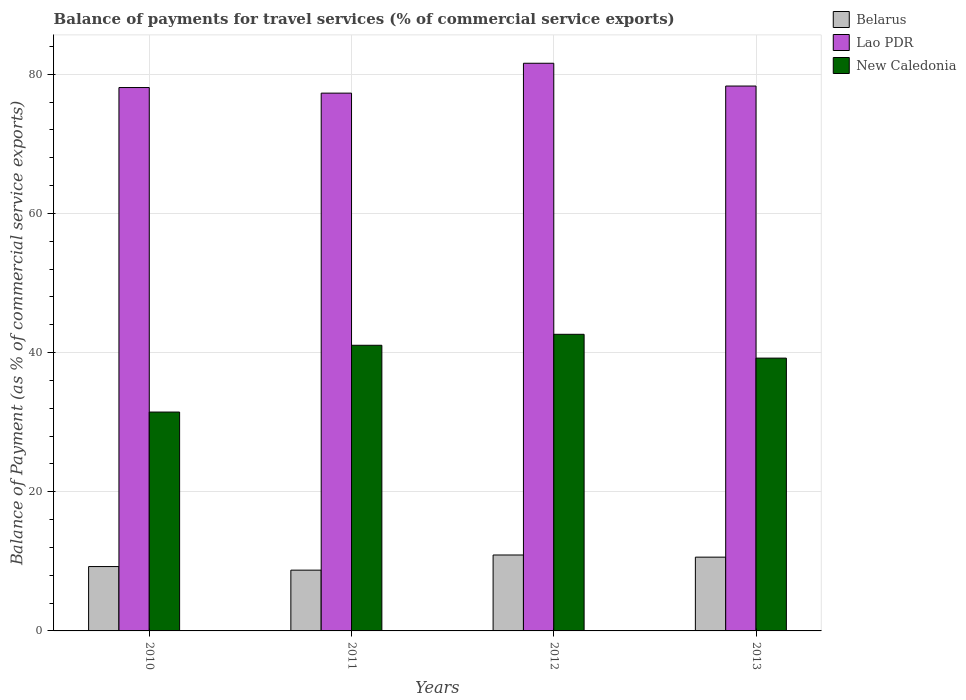How many bars are there on the 4th tick from the left?
Ensure brevity in your answer.  3. What is the label of the 4th group of bars from the left?
Make the answer very short. 2013. In how many cases, is the number of bars for a given year not equal to the number of legend labels?
Ensure brevity in your answer.  0. What is the balance of payments for travel services in Lao PDR in 2012?
Provide a short and direct response. 81.57. Across all years, what is the maximum balance of payments for travel services in New Caledonia?
Make the answer very short. 42.62. Across all years, what is the minimum balance of payments for travel services in New Caledonia?
Your response must be concise. 31.45. What is the total balance of payments for travel services in New Caledonia in the graph?
Keep it short and to the point. 154.33. What is the difference between the balance of payments for travel services in Belarus in 2010 and that in 2012?
Provide a succinct answer. -1.66. What is the difference between the balance of payments for travel services in New Caledonia in 2010 and the balance of payments for travel services in Belarus in 2012?
Make the answer very short. 20.54. What is the average balance of payments for travel services in Lao PDR per year?
Provide a short and direct response. 78.81. In the year 2011, what is the difference between the balance of payments for travel services in Lao PDR and balance of payments for travel services in New Caledonia?
Ensure brevity in your answer.  36.23. In how many years, is the balance of payments for travel services in Lao PDR greater than 64 %?
Provide a succinct answer. 4. What is the ratio of the balance of payments for travel services in Lao PDR in 2011 to that in 2013?
Make the answer very short. 0.99. Is the balance of payments for travel services in Lao PDR in 2011 less than that in 2012?
Give a very brief answer. Yes. Is the difference between the balance of payments for travel services in Lao PDR in 2011 and 2012 greater than the difference between the balance of payments for travel services in New Caledonia in 2011 and 2012?
Provide a short and direct response. No. What is the difference between the highest and the second highest balance of payments for travel services in New Caledonia?
Your answer should be compact. 1.57. What is the difference between the highest and the lowest balance of payments for travel services in Belarus?
Your answer should be very brief. 2.18. In how many years, is the balance of payments for travel services in New Caledonia greater than the average balance of payments for travel services in New Caledonia taken over all years?
Ensure brevity in your answer.  3. Is the sum of the balance of payments for travel services in Lao PDR in 2011 and 2013 greater than the maximum balance of payments for travel services in Belarus across all years?
Keep it short and to the point. Yes. What does the 1st bar from the left in 2011 represents?
Ensure brevity in your answer.  Belarus. What does the 3rd bar from the right in 2012 represents?
Offer a very short reply. Belarus. Is it the case that in every year, the sum of the balance of payments for travel services in Belarus and balance of payments for travel services in New Caledonia is greater than the balance of payments for travel services in Lao PDR?
Give a very brief answer. No. Are all the bars in the graph horizontal?
Make the answer very short. No. How many years are there in the graph?
Make the answer very short. 4. What is the difference between two consecutive major ticks on the Y-axis?
Keep it short and to the point. 20. Are the values on the major ticks of Y-axis written in scientific E-notation?
Ensure brevity in your answer.  No. Does the graph contain any zero values?
Offer a very short reply. No. Where does the legend appear in the graph?
Make the answer very short. Top right. What is the title of the graph?
Keep it short and to the point. Balance of payments for travel services (% of commercial service exports). What is the label or title of the Y-axis?
Keep it short and to the point. Balance of Payment (as % of commercial service exports). What is the Balance of Payment (as % of commercial service exports) in Belarus in 2010?
Offer a terse response. 9.25. What is the Balance of Payment (as % of commercial service exports) of Lao PDR in 2010?
Your answer should be very brief. 78.08. What is the Balance of Payment (as % of commercial service exports) in New Caledonia in 2010?
Your answer should be very brief. 31.45. What is the Balance of Payment (as % of commercial service exports) of Belarus in 2011?
Offer a terse response. 8.73. What is the Balance of Payment (as % of commercial service exports) of Lao PDR in 2011?
Provide a short and direct response. 77.28. What is the Balance of Payment (as % of commercial service exports) of New Caledonia in 2011?
Your answer should be very brief. 41.05. What is the Balance of Payment (as % of commercial service exports) in Belarus in 2012?
Your response must be concise. 10.91. What is the Balance of Payment (as % of commercial service exports) in Lao PDR in 2012?
Make the answer very short. 81.57. What is the Balance of Payment (as % of commercial service exports) of New Caledonia in 2012?
Make the answer very short. 42.62. What is the Balance of Payment (as % of commercial service exports) of Belarus in 2013?
Make the answer very short. 10.6. What is the Balance of Payment (as % of commercial service exports) in Lao PDR in 2013?
Your response must be concise. 78.3. What is the Balance of Payment (as % of commercial service exports) of New Caledonia in 2013?
Make the answer very short. 39.2. Across all years, what is the maximum Balance of Payment (as % of commercial service exports) of Belarus?
Give a very brief answer. 10.91. Across all years, what is the maximum Balance of Payment (as % of commercial service exports) in Lao PDR?
Your answer should be very brief. 81.57. Across all years, what is the maximum Balance of Payment (as % of commercial service exports) in New Caledonia?
Make the answer very short. 42.62. Across all years, what is the minimum Balance of Payment (as % of commercial service exports) of Belarus?
Provide a succinct answer. 8.73. Across all years, what is the minimum Balance of Payment (as % of commercial service exports) of Lao PDR?
Provide a succinct answer. 77.28. Across all years, what is the minimum Balance of Payment (as % of commercial service exports) of New Caledonia?
Provide a short and direct response. 31.45. What is the total Balance of Payment (as % of commercial service exports) of Belarus in the graph?
Offer a terse response. 39.49. What is the total Balance of Payment (as % of commercial service exports) of Lao PDR in the graph?
Your answer should be very brief. 315.24. What is the total Balance of Payment (as % of commercial service exports) in New Caledonia in the graph?
Offer a very short reply. 154.33. What is the difference between the Balance of Payment (as % of commercial service exports) of Belarus in 2010 and that in 2011?
Keep it short and to the point. 0.52. What is the difference between the Balance of Payment (as % of commercial service exports) in Lao PDR in 2010 and that in 2011?
Your answer should be very brief. 0.8. What is the difference between the Balance of Payment (as % of commercial service exports) in New Caledonia in 2010 and that in 2011?
Your answer should be very brief. -9.6. What is the difference between the Balance of Payment (as % of commercial service exports) of Belarus in 2010 and that in 2012?
Give a very brief answer. -1.66. What is the difference between the Balance of Payment (as % of commercial service exports) of Lao PDR in 2010 and that in 2012?
Offer a very short reply. -3.49. What is the difference between the Balance of Payment (as % of commercial service exports) of New Caledonia in 2010 and that in 2012?
Make the answer very short. -11.17. What is the difference between the Balance of Payment (as % of commercial service exports) of Belarus in 2010 and that in 2013?
Ensure brevity in your answer.  -1.35. What is the difference between the Balance of Payment (as % of commercial service exports) in Lao PDR in 2010 and that in 2013?
Provide a short and direct response. -0.22. What is the difference between the Balance of Payment (as % of commercial service exports) of New Caledonia in 2010 and that in 2013?
Your answer should be very brief. -7.75. What is the difference between the Balance of Payment (as % of commercial service exports) in Belarus in 2011 and that in 2012?
Offer a very short reply. -2.18. What is the difference between the Balance of Payment (as % of commercial service exports) in Lao PDR in 2011 and that in 2012?
Provide a succinct answer. -4.29. What is the difference between the Balance of Payment (as % of commercial service exports) of New Caledonia in 2011 and that in 2012?
Provide a succinct answer. -1.57. What is the difference between the Balance of Payment (as % of commercial service exports) of Belarus in 2011 and that in 2013?
Your response must be concise. -1.87. What is the difference between the Balance of Payment (as % of commercial service exports) of Lao PDR in 2011 and that in 2013?
Your response must be concise. -1.02. What is the difference between the Balance of Payment (as % of commercial service exports) in New Caledonia in 2011 and that in 2013?
Keep it short and to the point. 1.85. What is the difference between the Balance of Payment (as % of commercial service exports) of Belarus in 2012 and that in 2013?
Give a very brief answer. 0.31. What is the difference between the Balance of Payment (as % of commercial service exports) in Lao PDR in 2012 and that in 2013?
Make the answer very short. 3.27. What is the difference between the Balance of Payment (as % of commercial service exports) of New Caledonia in 2012 and that in 2013?
Your answer should be very brief. 3.42. What is the difference between the Balance of Payment (as % of commercial service exports) in Belarus in 2010 and the Balance of Payment (as % of commercial service exports) in Lao PDR in 2011?
Your answer should be very brief. -68.03. What is the difference between the Balance of Payment (as % of commercial service exports) of Belarus in 2010 and the Balance of Payment (as % of commercial service exports) of New Caledonia in 2011?
Provide a short and direct response. -31.8. What is the difference between the Balance of Payment (as % of commercial service exports) in Lao PDR in 2010 and the Balance of Payment (as % of commercial service exports) in New Caledonia in 2011?
Give a very brief answer. 37.03. What is the difference between the Balance of Payment (as % of commercial service exports) in Belarus in 2010 and the Balance of Payment (as % of commercial service exports) in Lao PDR in 2012?
Offer a very short reply. -72.32. What is the difference between the Balance of Payment (as % of commercial service exports) of Belarus in 2010 and the Balance of Payment (as % of commercial service exports) of New Caledonia in 2012?
Provide a short and direct response. -33.37. What is the difference between the Balance of Payment (as % of commercial service exports) in Lao PDR in 2010 and the Balance of Payment (as % of commercial service exports) in New Caledonia in 2012?
Offer a very short reply. 35.46. What is the difference between the Balance of Payment (as % of commercial service exports) in Belarus in 2010 and the Balance of Payment (as % of commercial service exports) in Lao PDR in 2013?
Ensure brevity in your answer.  -69.05. What is the difference between the Balance of Payment (as % of commercial service exports) in Belarus in 2010 and the Balance of Payment (as % of commercial service exports) in New Caledonia in 2013?
Give a very brief answer. -29.95. What is the difference between the Balance of Payment (as % of commercial service exports) in Lao PDR in 2010 and the Balance of Payment (as % of commercial service exports) in New Caledonia in 2013?
Give a very brief answer. 38.88. What is the difference between the Balance of Payment (as % of commercial service exports) in Belarus in 2011 and the Balance of Payment (as % of commercial service exports) in Lao PDR in 2012?
Offer a very short reply. -72.84. What is the difference between the Balance of Payment (as % of commercial service exports) in Belarus in 2011 and the Balance of Payment (as % of commercial service exports) in New Caledonia in 2012?
Your answer should be compact. -33.89. What is the difference between the Balance of Payment (as % of commercial service exports) in Lao PDR in 2011 and the Balance of Payment (as % of commercial service exports) in New Caledonia in 2012?
Your answer should be very brief. 34.66. What is the difference between the Balance of Payment (as % of commercial service exports) of Belarus in 2011 and the Balance of Payment (as % of commercial service exports) of Lao PDR in 2013?
Your answer should be compact. -69.57. What is the difference between the Balance of Payment (as % of commercial service exports) in Belarus in 2011 and the Balance of Payment (as % of commercial service exports) in New Caledonia in 2013?
Give a very brief answer. -30.47. What is the difference between the Balance of Payment (as % of commercial service exports) of Lao PDR in 2011 and the Balance of Payment (as % of commercial service exports) of New Caledonia in 2013?
Give a very brief answer. 38.08. What is the difference between the Balance of Payment (as % of commercial service exports) of Belarus in 2012 and the Balance of Payment (as % of commercial service exports) of Lao PDR in 2013?
Give a very brief answer. -67.39. What is the difference between the Balance of Payment (as % of commercial service exports) in Belarus in 2012 and the Balance of Payment (as % of commercial service exports) in New Caledonia in 2013?
Provide a short and direct response. -28.29. What is the difference between the Balance of Payment (as % of commercial service exports) in Lao PDR in 2012 and the Balance of Payment (as % of commercial service exports) in New Caledonia in 2013?
Offer a terse response. 42.37. What is the average Balance of Payment (as % of commercial service exports) of Belarus per year?
Your answer should be compact. 9.87. What is the average Balance of Payment (as % of commercial service exports) of Lao PDR per year?
Offer a terse response. 78.81. What is the average Balance of Payment (as % of commercial service exports) in New Caledonia per year?
Your response must be concise. 38.58. In the year 2010, what is the difference between the Balance of Payment (as % of commercial service exports) of Belarus and Balance of Payment (as % of commercial service exports) of Lao PDR?
Keep it short and to the point. -68.83. In the year 2010, what is the difference between the Balance of Payment (as % of commercial service exports) of Belarus and Balance of Payment (as % of commercial service exports) of New Caledonia?
Provide a short and direct response. -22.2. In the year 2010, what is the difference between the Balance of Payment (as % of commercial service exports) in Lao PDR and Balance of Payment (as % of commercial service exports) in New Caledonia?
Provide a succinct answer. 46.63. In the year 2011, what is the difference between the Balance of Payment (as % of commercial service exports) in Belarus and Balance of Payment (as % of commercial service exports) in Lao PDR?
Your answer should be compact. -68.55. In the year 2011, what is the difference between the Balance of Payment (as % of commercial service exports) in Belarus and Balance of Payment (as % of commercial service exports) in New Caledonia?
Offer a very short reply. -32.32. In the year 2011, what is the difference between the Balance of Payment (as % of commercial service exports) in Lao PDR and Balance of Payment (as % of commercial service exports) in New Caledonia?
Ensure brevity in your answer.  36.23. In the year 2012, what is the difference between the Balance of Payment (as % of commercial service exports) in Belarus and Balance of Payment (as % of commercial service exports) in Lao PDR?
Make the answer very short. -70.66. In the year 2012, what is the difference between the Balance of Payment (as % of commercial service exports) of Belarus and Balance of Payment (as % of commercial service exports) of New Caledonia?
Offer a terse response. -31.71. In the year 2012, what is the difference between the Balance of Payment (as % of commercial service exports) in Lao PDR and Balance of Payment (as % of commercial service exports) in New Caledonia?
Keep it short and to the point. 38.95. In the year 2013, what is the difference between the Balance of Payment (as % of commercial service exports) of Belarus and Balance of Payment (as % of commercial service exports) of Lao PDR?
Offer a terse response. -67.7. In the year 2013, what is the difference between the Balance of Payment (as % of commercial service exports) of Belarus and Balance of Payment (as % of commercial service exports) of New Caledonia?
Offer a very short reply. -28.6. In the year 2013, what is the difference between the Balance of Payment (as % of commercial service exports) in Lao PDR and Balance of Payment (as % of commercial service exports) in New Caledonia?
Provide a succinct answer. 39.1. What is the ratio of the Balance of Payment (as % of commercial service exports) of Belarus in 2010 to that in 2011?
Your answer should be very brief. 1.06. What is the ratio of the Balance of Payment (as % of commercial service exports) of Lao PDR in 2010 to that in 2011?
Your answer should be very brief. 1.01. What is the ratio of the Balance of Payment (as % of commercial service exports) of New Caledonia in 2010 to that in 2011?
Your response must be concise. 0.77. What is the ratio of the Balance of Payment (as % of commercial service exports) in Belarus in 2010 to that in 2012?
Ensure brevity in your answer.  0.85. What is the ratio of the Balance of Payment (as % of commercial service exports) of Lao PDR in 2010 to that in 2012?
Offer a terse response. 0.96. What is the ratio of the Balance of Payment (as % of commercial service exports) in New Caledonia in 2010 to that in 2012?
Your answer should be very brief. 0.74. What is the ratio of the Balance of Payment (as % of commercial service exports) of Belarus in 2010 to that in 2013?
Give a very brief answer. 0.87. What is the ratio of the Balance of Payment (as % of commercial service exports) in Lao PDR in 2010 to that in 2013?
Your answer should be compact. 1. What is the ratio of the Balance of Payment (as % of commercial service exports) of New Caledonia in 2010 to that in 2013?
Offer a terse response. 0.8. What is the ratio of the Balance of Payment (as % of commercial service exports) in Belarus in 2011 to that in 2012?
Provide a short and direct response. 0.8. What is the ratio of the Balance of Payment (as % of commercial service exports) in Lao PDR in 2011 to that in 2012?
Keep it short and to the point. 0.95. What is the ratio of the Balance of Payment (as % of commercial service exports) in New Caledonia in 2011 to that in 2012?
Provide a short and direct response. 0.96. What is the ratio of the Balance of Payment (as % of commercial service exports) in Belarus in 2011 to that in 2013?
Keep it short and to the point. 0.82. What is the ratio of the Balance of Payment (as % of commercial service exports) in New Caledonia in 2011 to that in 2013?
Your response must be concise. 1.05. What is the ratio of the Balance of Payment (as % of commercial service exports) of Belarus in 2012 to that in 2013?
Provide a succinct answer. 1.03. What is the ratio of the Balance of Payment (as % of commercial service exports) in Lao PDR in 2012 to that in 2013?
Offer a very short reply. 1.04. What is the ratio of the Balance of Payment (as % of commercial service exports) in New Caledonia in 2012 to that in 2013?
Make the answer very short. 1.09. What is the difference between the highest and the second highest Balance of Payment (as % of commercial service exports) of Belarus?
Keep it short and to the point. 0.31. What is the difference between the highest and the second highest Balance of Payment (as % of commercial service exports) of Lao PDR?
Your response must be concise. 3.27. What is the difference between the highest and the second highest Balance of Payment (as % of commercial service exports) in New Caledonia?
Provide a short and direct response. 1.57. What is the difference between the highest and the lowest Balance of Payment (as % of commercial service exports) in Belarus?
Your answer should be compact. 2.18. What is the difference between the highest and the lowest Balance of Payment (as % of commercial service exports) of Lao PDR?
Provide a succinct answer. 4.29. What is the difference between the highest and the lowest Balance of Payment (as % of commercial service exports) of New Caledonia?
Offer a terse response. 11.17. 